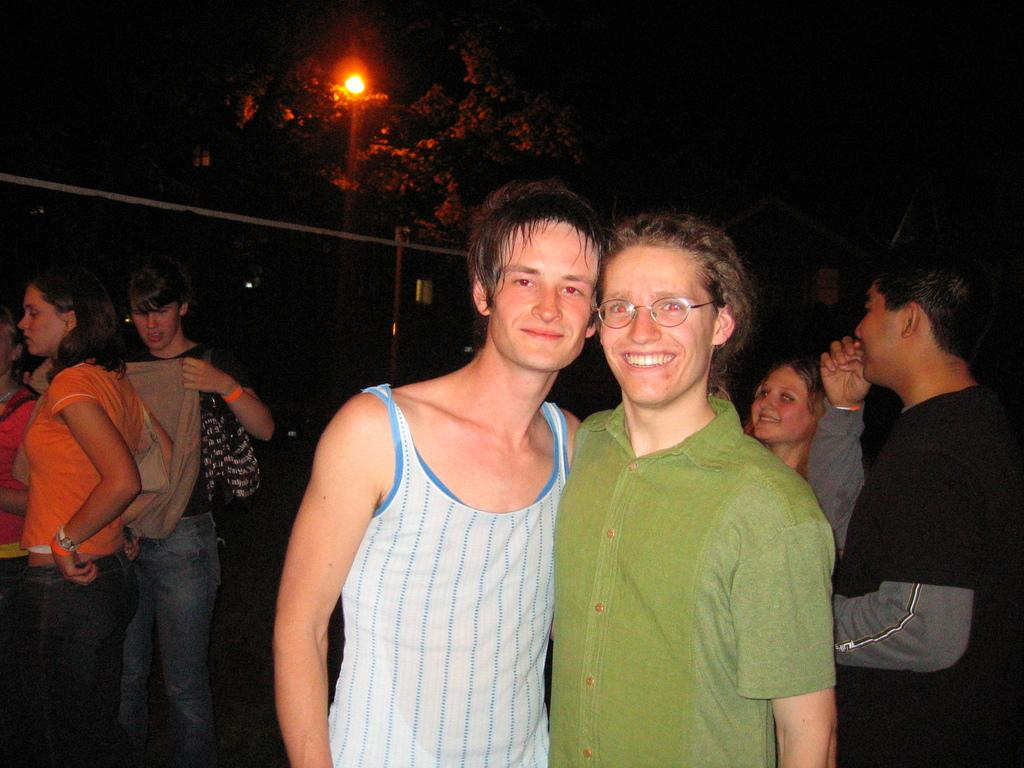How many men are in the image? There are two men standing in the image. What can be observed about the background of the image? The background of the image is dark, and there are persons, light, trees, a pole, wires, and houses visible. Can you describe the lighting situation in the background of the image? There is light visible in the background of the image. What type of structures can be seen in the background of the image? Houses are present in the background of the image. What type of dime is being used to pay for breakfast in the image? There is no dime or breakfast present in the image. What type of hose is being used by the men in the image? There is no hose visible in the image. 